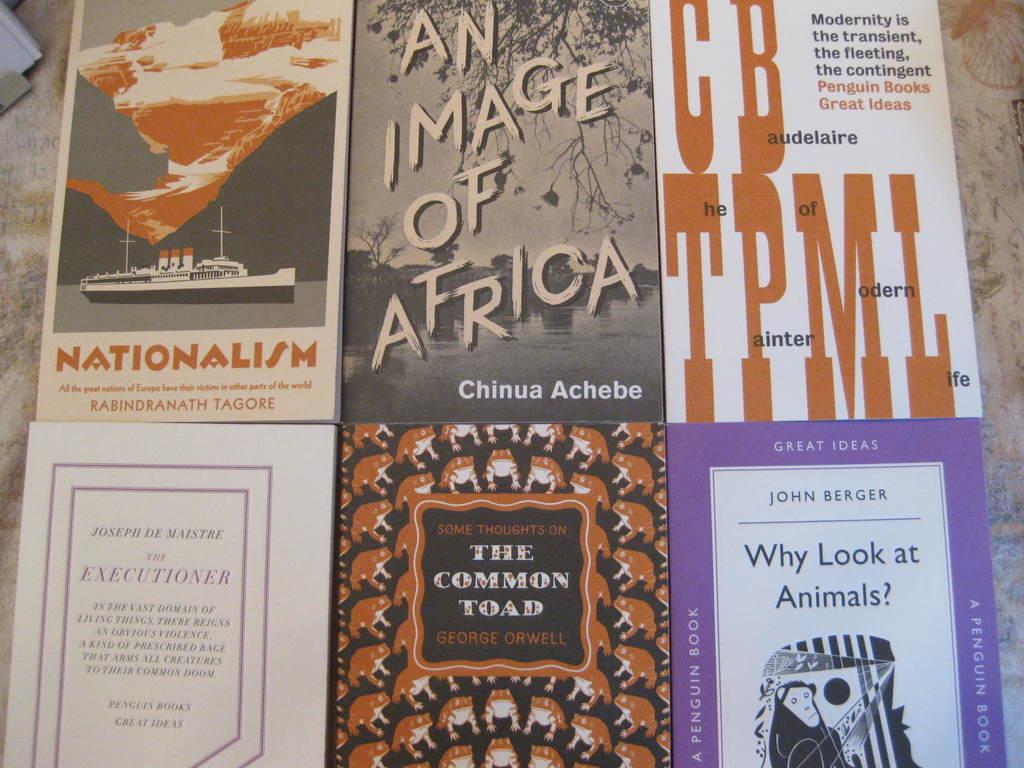Who authored the common toad?
Keep it short and to the point. George orwell. What book did john berger write?
Keep it short and to the point. Why look at animals?. 